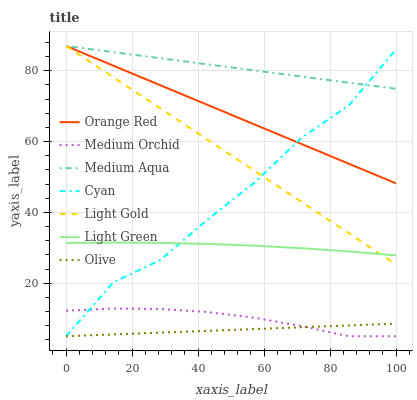Does Olive have the minimum area under the curve?
Answer yes or no. Yes. Does Medium Aqua have the maximum area under the curve?
Answer yes or no. Yes. Does Light Green have the minimum area under the curve?
Answer yes or no. No. Does Light Green have the maximum area under the curve?
Answer yes or no. No. Is Olive the smoothest?
Answer yes or no. Yes. Is Cyan the roughest?
Answer yes or no. Yes. Is Medium Aqua the smoothest?
Answer yes or no. No. Is Medium Aqua the roughest?
Answer yes or no. No. Does Medium Orchid have the lowest value?
Answer yes or no. Yes. Does Light Green have the lowest value?
Answer yes or no. No. Does Orange Red have the highest value?
Answer yes or no. Yes. Does Light Green have the highest value?
Answer yes or no. No. Is Light Green less than Orange Red?
Answer yes or no. Yes. Is Medium Aqua greater than Medium Orchid?
Answer yes or no. Yes. Does Cyan intersect Light Gold?
Answer yes or no. Yes. Is Cyan less than Light Gold?
Answer yes or no. No. Is Cyan greater than Light Gold?
Answer yes or no. No. Does Light Green intersect Orange Red?
Answer yes or no. No. 